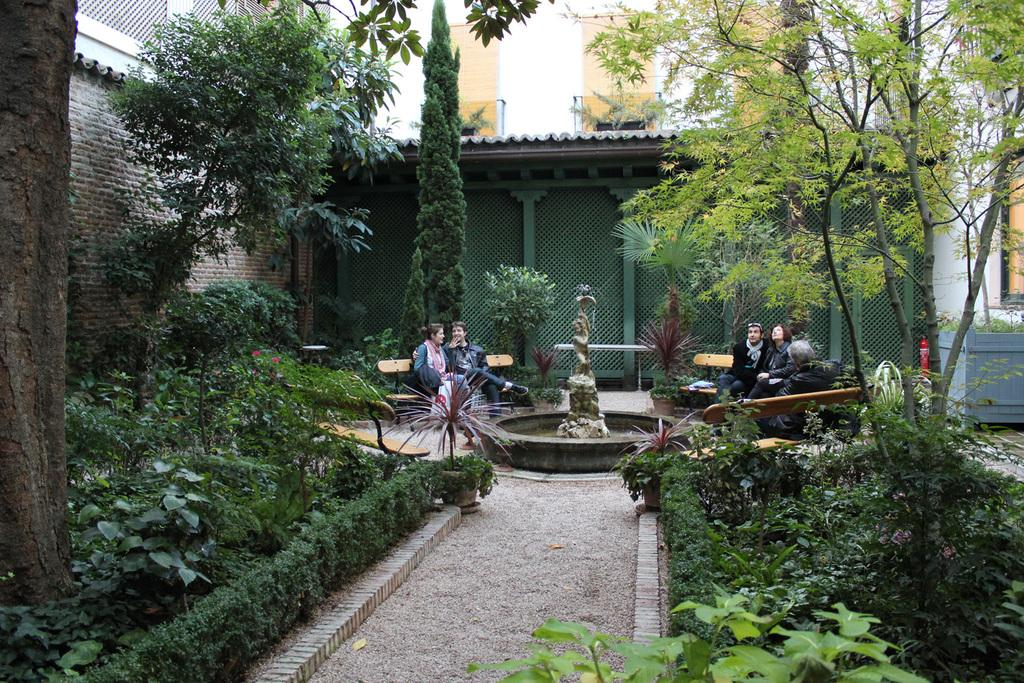How many people are sitting on the bench in the image? There are four persons sitting on a bench in the image. What type of vegetation can be seen in the image? There are trees with green leaves in the image. What color is the railing in the image? The railing in the image is green. What color is the building in the image? The building in the image has a white color. What type of desk can be seen in the image? There is no desk present in the image. What color are the clouds in the image? There are no clouds visible in the image. 